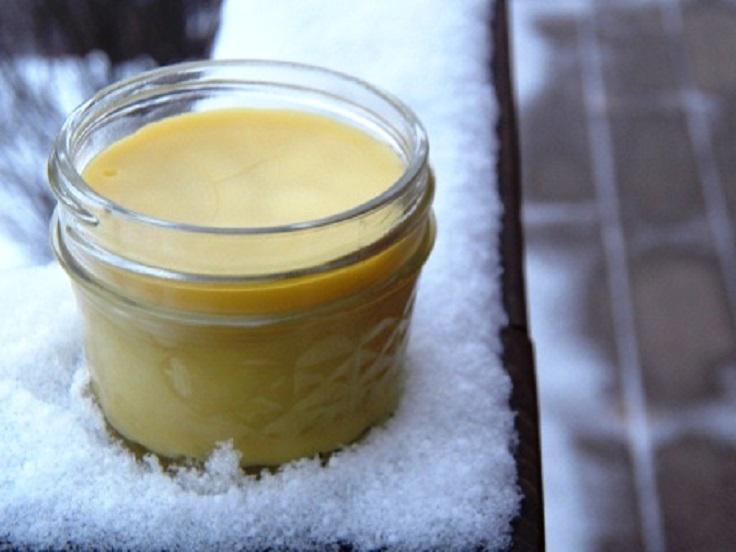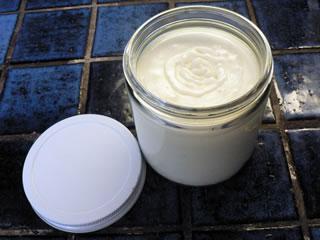The first image is the image on the left, the second image is the image on the right. Considering the images on both sides, is "Left and right images show similarly-shaped clear glass open-topped jars containing a creamy substance." valid? Answer yes or no. Yes. The first image is the image on the left, the second image is the image on the right. Examine the images to the left and right. Is the description "There are two glass jars and they are both open." accurate? Answer yes or no. Yes. 